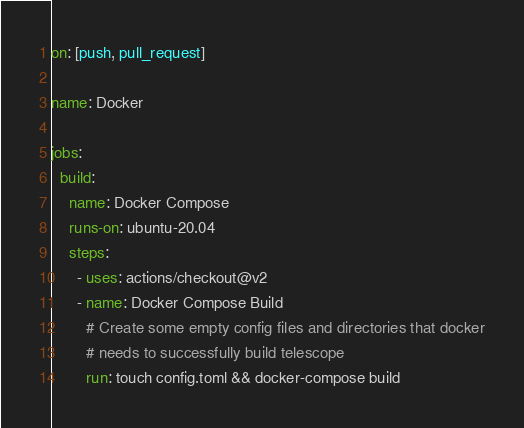<code> <loc_0><loc_0><loc_500><loc_500><_YAML_>on: [push, pull_request]

name: Docker

jobs:
  build:
    name: Docker Compose
    runs-on: ubuntu-20.04
    steps:
      - uses: actions/checkout@v2
      - name: Docker Compose Build
        # Create some empty config files and directories that docker
        # needs to successfully build telescope
        run: touch config.toml && docker-compose build
</code> 